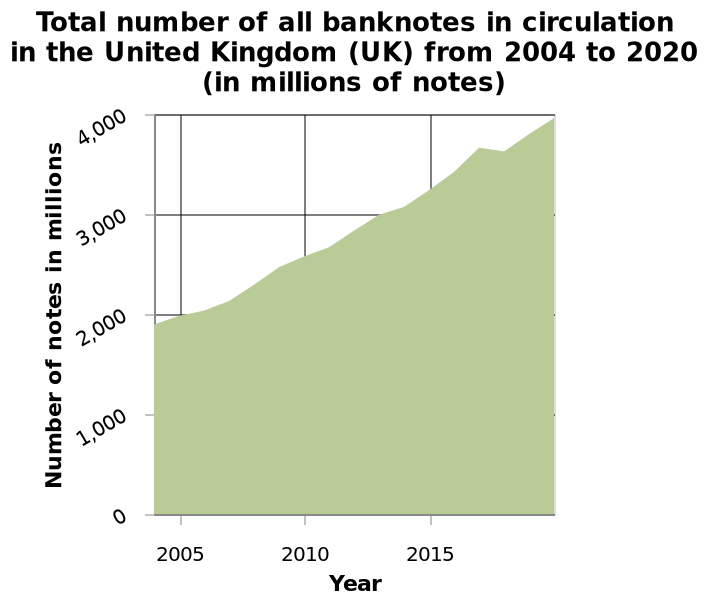<image>
How would you describe the trend of the number of banknotes in circulation during the timeframe? The trend of the number of banknotes in circulation was consistently upward, reaching its peak at the end of the period. Was there a decrease in the number of banknotes during the timeframe? No, there was a steady increase in the number of banknotes. What is the label of the area chart?  The area chart is labeled "Total number of all banknotes in circulation in the United Kingdom (UK) from 2004 to 2020 (in millions of notes)." 